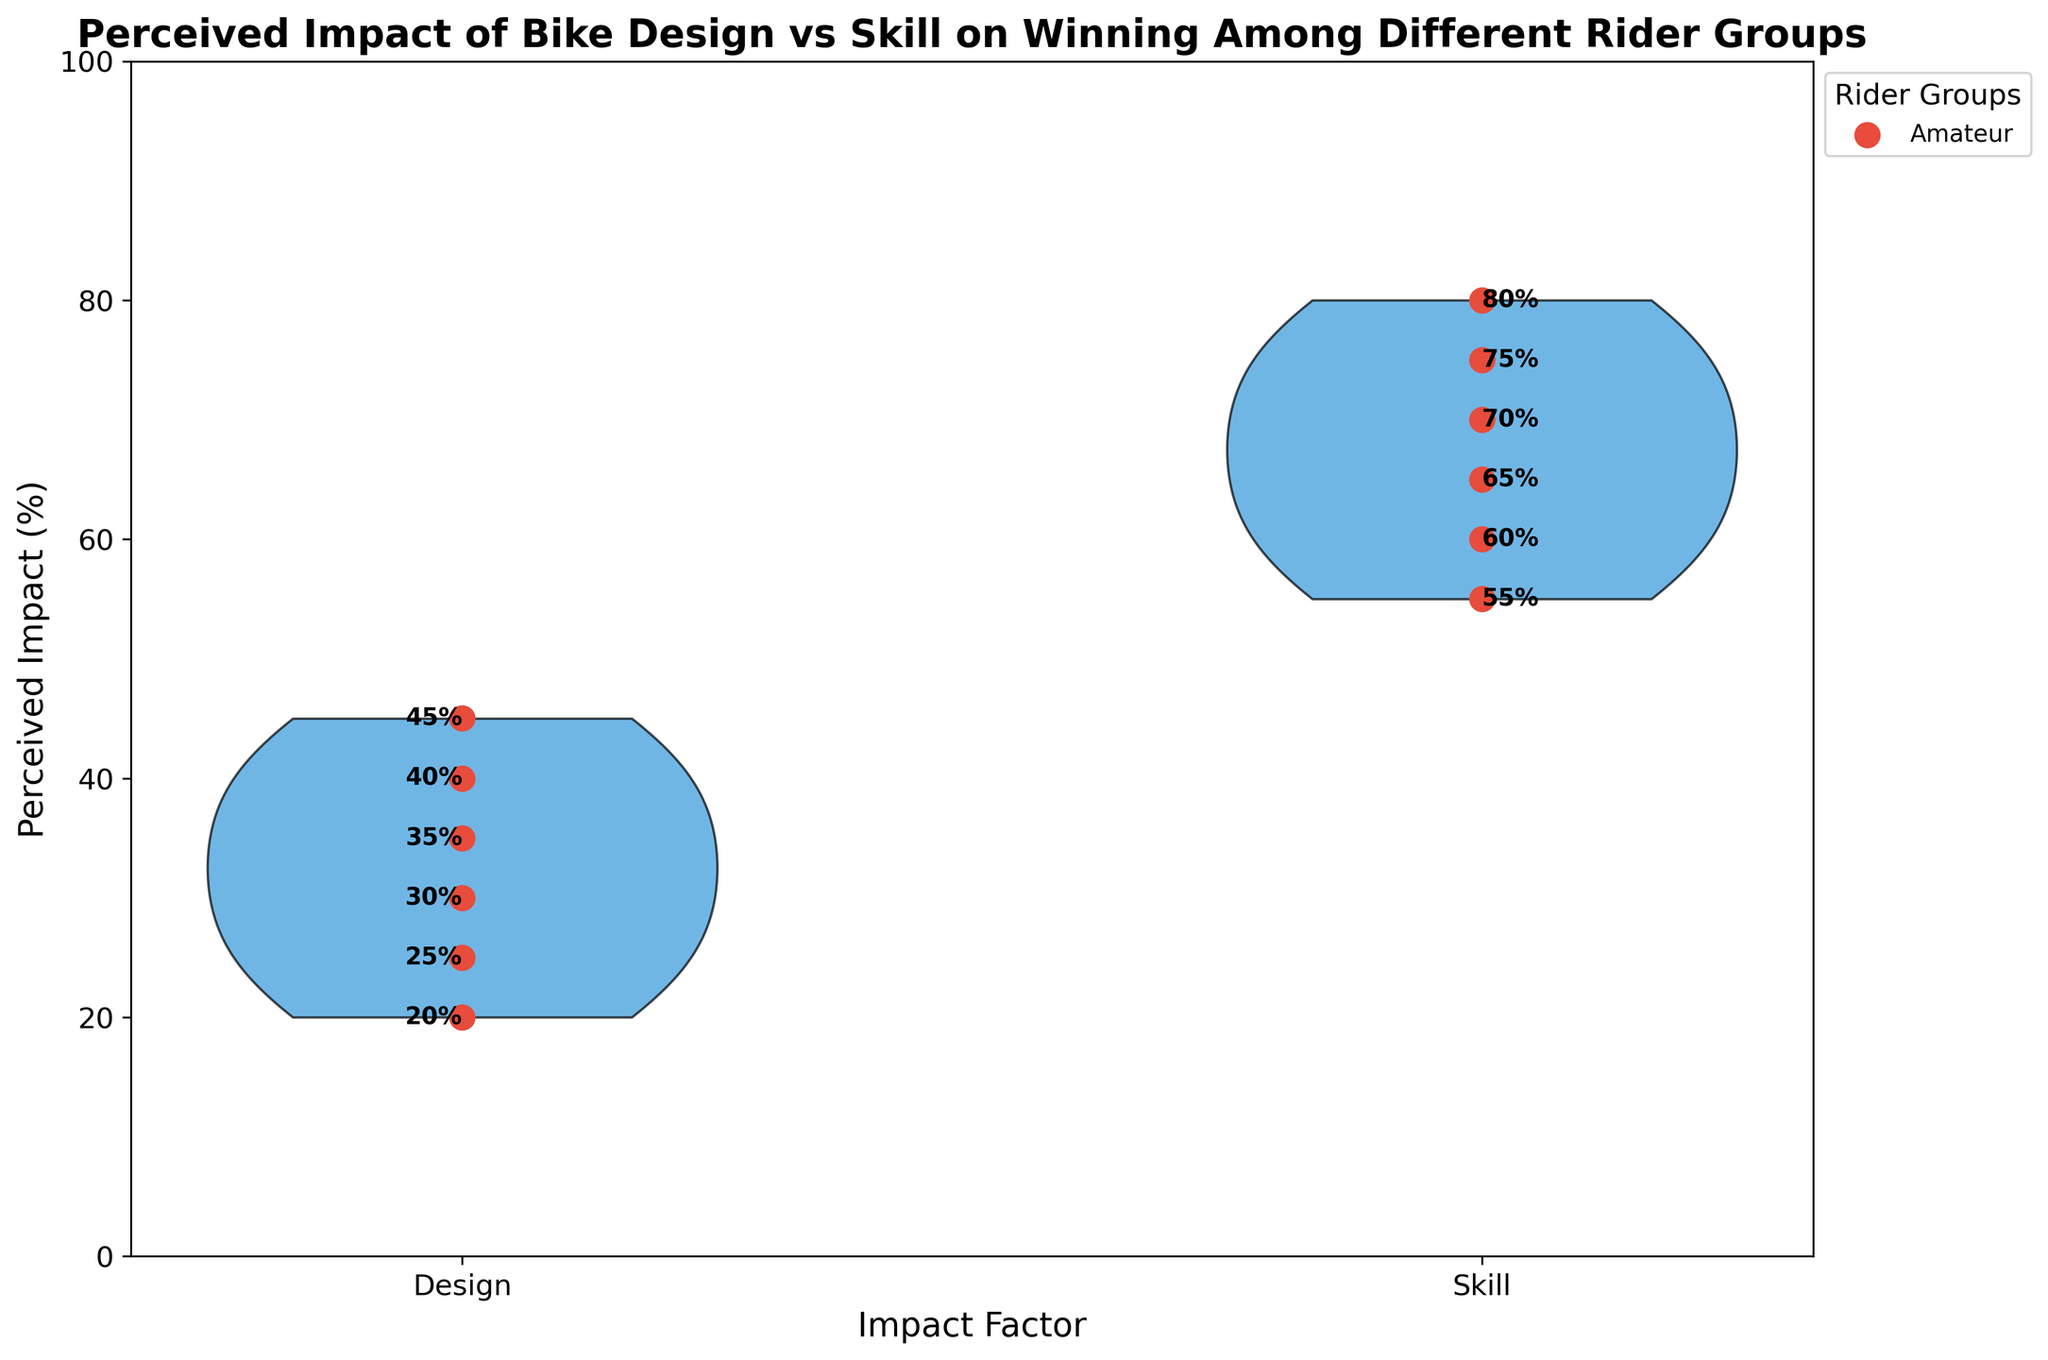What's the title of the plot? The title of the plot is prominently displayed at the top of the figure.
Answer: Perceived Impact of Bike Design vs Skill on Winning Among Different Rider Groups What are the labels on the x-axis? The x-axis displays two categories, one for each of the perceived impacts. These categories are written below the x-axis.
Answer: Design, Skill Which rider group perceives the highest impact from skill? Look for the highest value on the side of the violin plot corresponding to skill. Identify the rider group associated with this value.
Answer: Master What's the difference between the perceived impact of skill and design for the Amateur group? Subtract the value corresponding to design from the value corresponding to skill for the Amateur group. The values are 70 and 30, respectively.
Answer: 40 Which rider group has the smallest difference between the perceived impact of design and skill? Calculate the difference between the design and skill impact values for each group, and identify the group with the smallest absolute difference. The values are 30/70 for Amateur, 40/60 for Enthusiast, 45/55 for Competitive, 35/65 for Professional, 25/75 for Pro Circuit, and 20/80 for Master. The smallest difference is 10 for the Competitive group.
Answer: Competitive What color represents the individual data points for rider groups? The scatter plot data points are displayed in a distinct color, which can be seen on the plot for each rider group.
Answer: Red How many data points are included in the plot for the perceived impact of design? Count the number of individual data points on the design side of the violin plot, representing each rider group's perceived impact. There is one data point per group, and there are six groups in total.
Answer: 6 Which side (Design or Skill) has a higher average perceived impact across all rider groups? Calculate the average for design values: (30+40+45+35+25+20)/6 = 32.5. Calculate the average for skill values: (70+60+55+65+75+80)/6 = 67.5. The side with the higher average is Skill.
Answer: Skill 